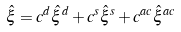Convert formula to latex. <formula><loc_0><loc_0><loc_500><loc_500>\hat { \xi } = c ^ { d } \hat { \xi } ^ { d } + c ^ { s } \hat { \xi } ^ { s } + c ^ { a c } \hat { \xi } ^ { a c }</formula> 